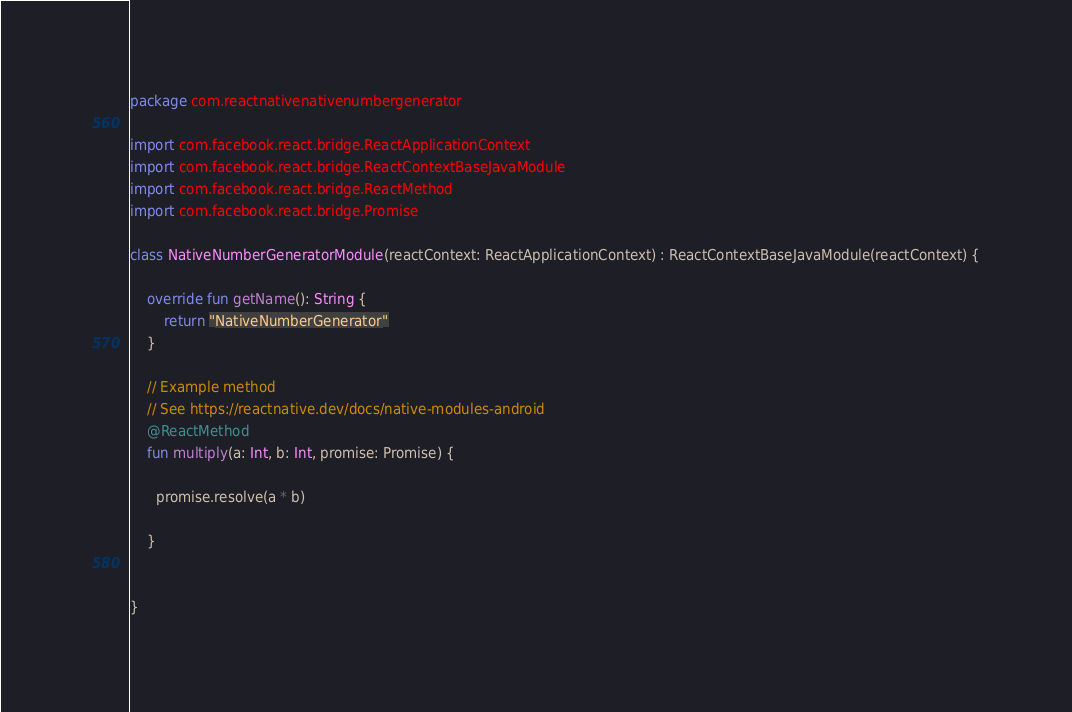<code> <loc_0><loc_0><loc_500><loc_500><_Kotlin_>package com.reactnativenativenumbergenerator

import com.facebook.react.bridge.ReactApplicationContext
import com.facebook.react.bridge.ReactContextBaseJavaModule
import com.facebook.react.bridge.ReactMethod
import com.facebook.react.bridge.Promise

class NativeNumberGeneratorModule(reactContext: ReactApplicationContext) : ReactContextBaseJavaModule(reactContext) {

    override fun getName(): String {
        return "NativeNumberGenerator"
    }

    // Example method
    // See https://reactnative.dev/docs/native-modules-android
    @ReactMethod
    fun multiply(a: Int, b: Int, promise: Promise) {
    
      promise.resolve(a * b)
    
    }

    
}
</code> 